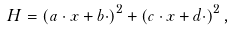Convert formula to latex. <formula><loc_0><loc_0><loc_500><loc_500>H = \left ( a \cdot x + b \cdot \right ) ^ { 2 } + \left ( c \cdot x + d \cdot \right ) ^ { 2 } ,</formula> 